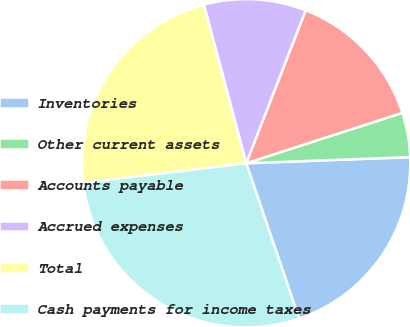Convert chart to OTSL. <chart><loc_0><loc_0><loc_500><loc_500><pie_chart><fcel>Inventories<fcel>Other current assets<fcel>Accounts payable<fcel>Accrued expenses<fcel>Total<fcel>Cash payments for income taxes<nl><fcel>20.37%<fcel>4.38%<fcel>14.12%<fcel>10.06%<fcel>22.76%<fcel>28.32%<nl></chart> 